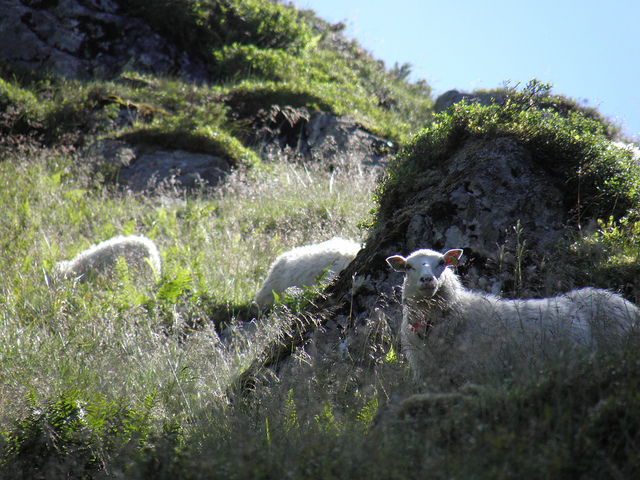Can you describe the setting of the photo? The photo captures a serene pastoral scene, likely set on a hillside. The undulating terrain is covered with fresh, verdant grass and sporadic rocky outcrops, creating a natural habitat that seems perfect for grazing sheep. The overall atmosphere suggests a secluded, peaceful location, away from the hustle and bustle of urban life. Do the sheep appear to be a particular breed? While it’s challenging to definitively identify the breed without closer inspection, the sheep do possess characteristics such as white fleece and pointed ears, which are common to many breeds found in pastoral settings. A more detailed photograph would be needed to accurately determine the breed. 